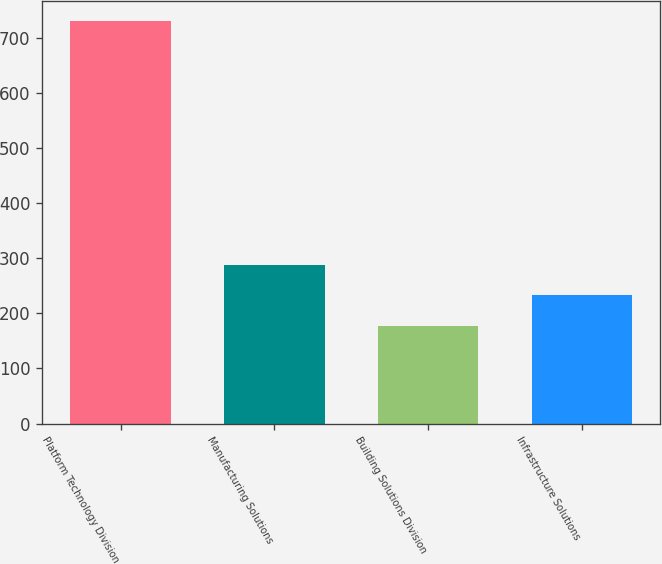Convert chart. <chart><loc_0><loc_0><loc_500><loc_500><bar_chart><fcel>Platform Technology Division<fcel>Manufacturing Solutions<fcel>Building Solutions Division<fcel>Infrastructure Solutions<nl><fcel>731.6<fcel>288.4<fcel>177.6<fcel>233<nl></chart> 